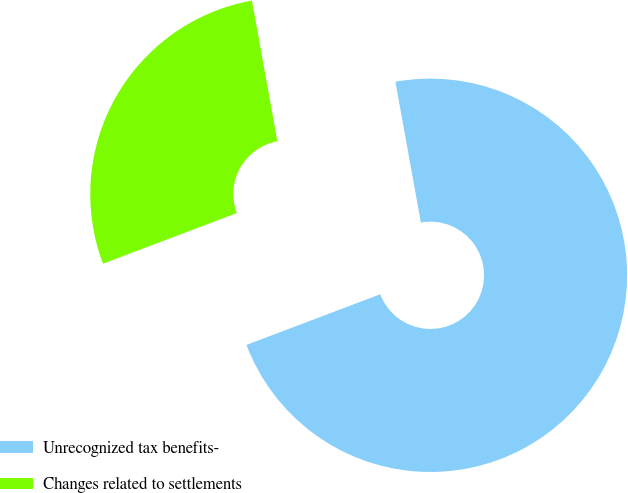Convert chart. <chart><loc_0><loc_0><loc_500><loc_500><pie_chart><fcel>Unrecognized tax benefits-<fcel>Changes related to settlements<nl><fcel>72.09%<fcel>27.91%<nl></chart> 